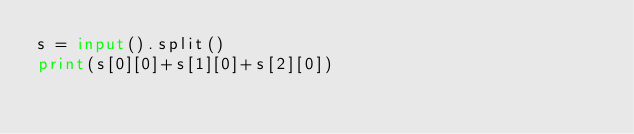<code> <loc_0><loc_0><loc_500><loc_500><_Python_>s = input().split()
print(s[0][0]+s[1][0]+s[2][0])</code> 